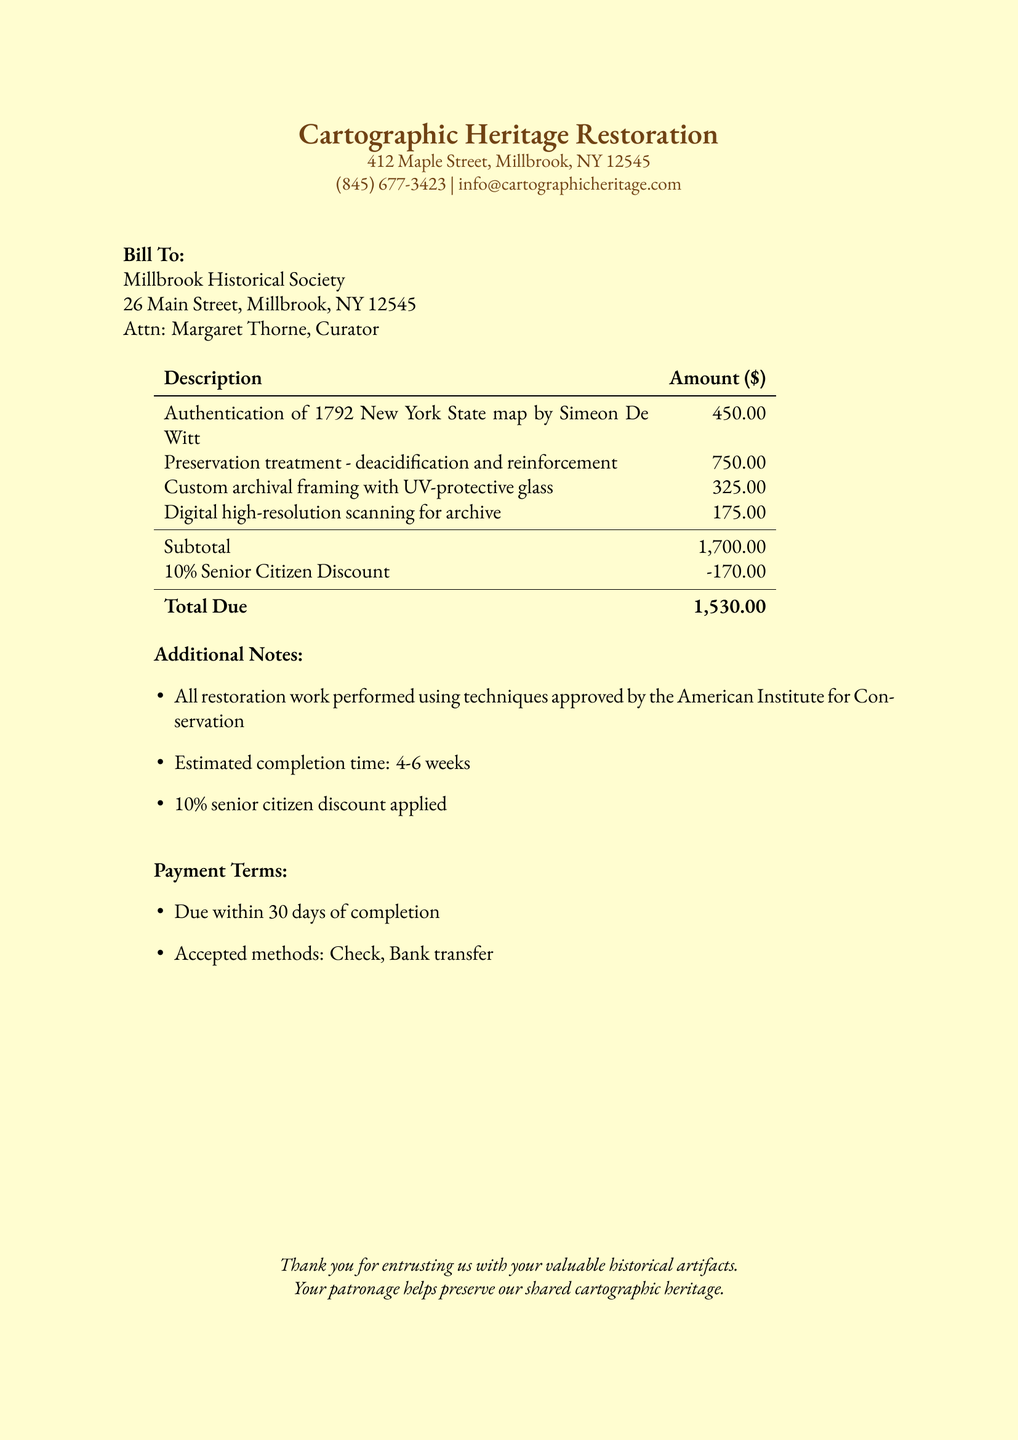What is the name of the service provider? The service provider is identified at the top of the document as "Cartographic Heritage Restoration."
Answer: Cartographic Heritage Restoration Who is the bill addressed to? The bill is directed to the "Millbrook Historical Society."
Answer: Millbrook Historical Society What is the total amount due? The total due is explicitly stated at the end of the bill as "1,530.00."
Answer: 1,530.00 What discount is applied? A 10% discount for senior citizens is noted in the document.
Answer: 10% Senior Citizen Discount What is the estimated completion time for the restoration work? The document states the estimated completion time as "4-6 weeks."
Answer: 4-6 weeks What is the amount charged for custom archival framing? The charge for custom archival framing is listed as "325.00."
Answer: 325.00 What methods of payment are accepted? The document specifies "Check, Bank transfer" as the accepted payment methods.
Answer: Check, Bank transfer What preservation technique is performed on the map? The preservation treatment includes "deacidification and reinforcement."
Answer: deacidification and reinforcement Who is the contact person mentioned in the bill? The document indicates that the contact person is "Margaret Thorne, Curator."
Answer: Margaret Thorne, Curator 